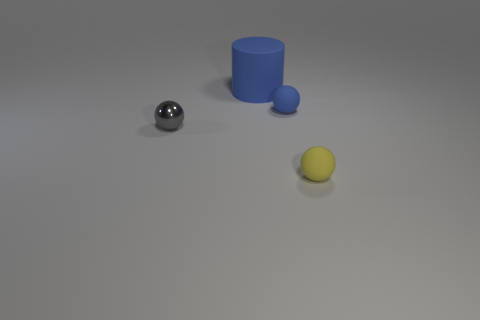Add 3 large blue matte cylinders. How many objects exist? 7 Subtract all gray metal spheres. How many spheres are left? 2 Subtract all blue spheres. How many spheres are left? 2 Subtract all spheres. How many objects are left? 1 Subtract all brown balls. Subtract all green cubes. How many balls are left? 3 Subtract all cyan cylinders. How many gray spheres are left? 1 Subtract all small green rubber cylinders. Subtract all balls. How many objects are left? 1 Add 3 gray balls. How many gray balls are left? 4 Add 1 cyan rubber things. How many cyan rubber things exist? 1 Subtract 1 yellow balls. How many objects are left? 3 